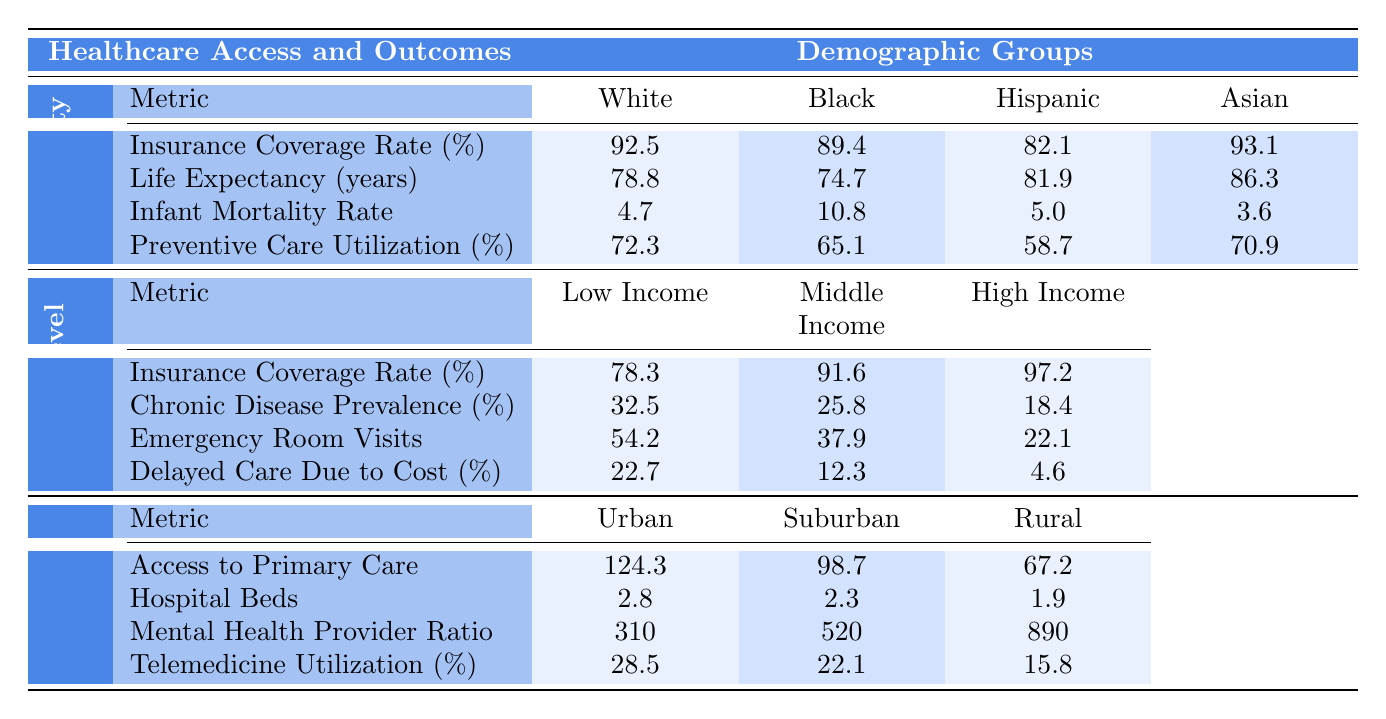What is the insurance coverage rate for Asian individuals? The table shows that the insurance coverage rate for Asian individuals is 93.1%.
Answer: 93.1% Which demographic group has the highest life expectancy? According to the table, the life expectancy for Asians is highest at 86.3 years.
Answer: Asians What is the infant mortality rate for Black individuals? The table indicates that the infant mortality rate for Black individuals is 10.8 per 1,000 live births.
Answer: 10.8 Among the income levels, which group exhibits the lowest insurance coverage rate? The table lists the insurance coverage rate for Low Income individuals as 78.3%, which is lower than both Middle Income and High Income groups.
Answer: Low Income What is the difference in preventive care utilization between White and Hispanic individuals? The preventive care utilization for White individuals is 72.3% and for Hispanic individuals is 58.7%. The difference is 72.3 - 58.7 = 13.6%.
Answer: 13.6% Is it true that the chronic disease prevalence is lower for High Income compared to Low Income? The chronic disease prevalence for High Income is 18.4% and for Low Income is 32.5%, which confirms that High Income has a lower rate.
Answer: True Which demographic group has the highest rate of emergency room visits? The emergency room visits for Low Income are 54.2 per 100 people, which is higher than the rates for both Middle Income and High Income groups.
Answer: Low Income What is the average life expectancy across all racial/ethnic groups listed in the table? The life expectancy values are 78.8 (White), 74.7 (Black), 81.9 (Hispanic), and 86.3 (Asian). The average is (78.8 + 74.7 + 81.9 + 86.3) / 4 = 80.4 years.
Answer: 80.4 In which geographic location is telemedicine utilization highest? The table specifies that telemedicine utilization is highest in Urban areas at 28.5%.
Answer: Urban How does the access to primary care in Rural areas compare to Urban areas? Urban areas have 124.3 physicians per 100,000, while Rural areas have 67.2. The difference is 124.3 - 67.2 = 57.1 fewer physicians in Rural areas.
Answer: 57.1 fewer physicians What percentage of Low Income individuals delayed care due to cost? The table shows that 22.7% of Low Income individuals reported delaying care due to cost.
Answer: 22.7% Is the mental health provider ratio better in Rural or Urban areas? The table indicates a mental health provider ratio of 310 in Urban areas compared to 890 in Rural areas, meaning Urban areas have better access.
Answer: Urban areas have better access 